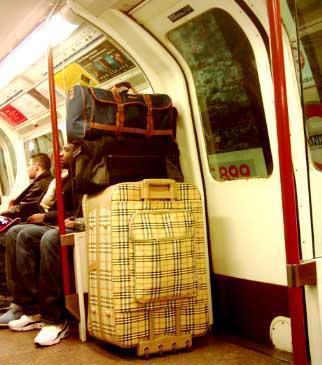How many handbags are there?
Give a very brief answer. 1. How many tires on the truck are visible?
Give a very brief answer. 0. 